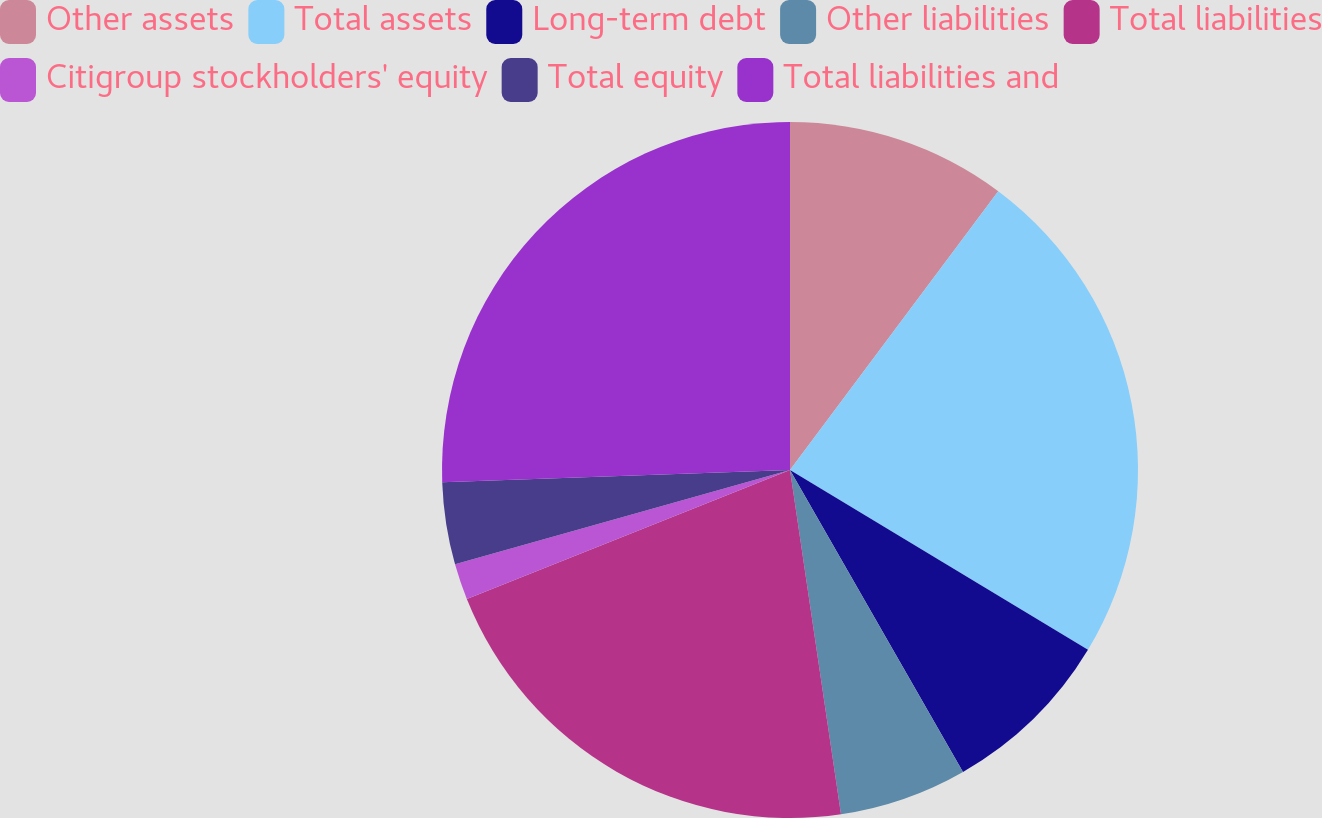Convert chart. <chart><loc_0><loc_0><loc_500><loc_500><pie_chart><fcel>Other assets<fcel>Total assets<fcel>Long-term debt<fcel>Other liabilities<fcel>Total liabilities<fcel>Citigroup stockholders' equity<fcel>Total equity<fcel>Total liabilities and<nl><fcel>10.21%<fcel>23.43%<fcel>8.08%<fcel>5.94%<fcel>21.29%<fcel>1.68%<fcel>3.81%<fcel>25.56%<nl></chart> 